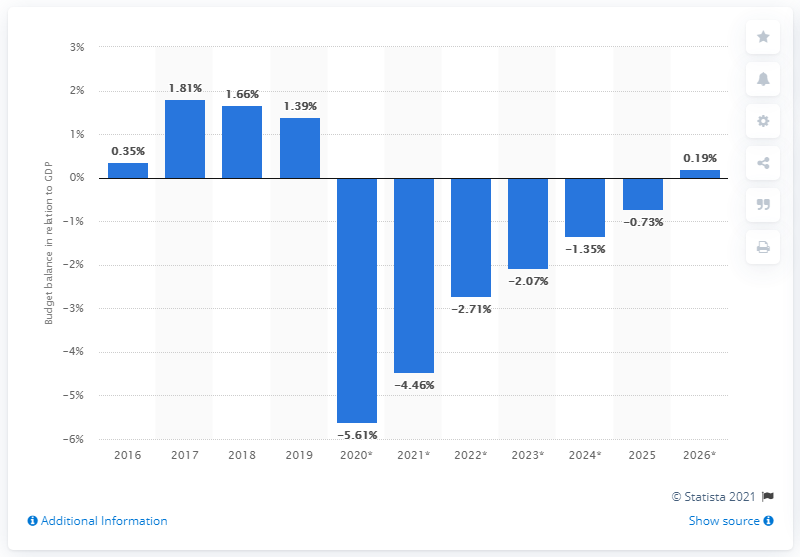Specify some key components in this picture. Bosnia and Herzegovina registered a budget surplus of 1.39 in 2019, indicating a significant improvement from the previous year's deficit. 